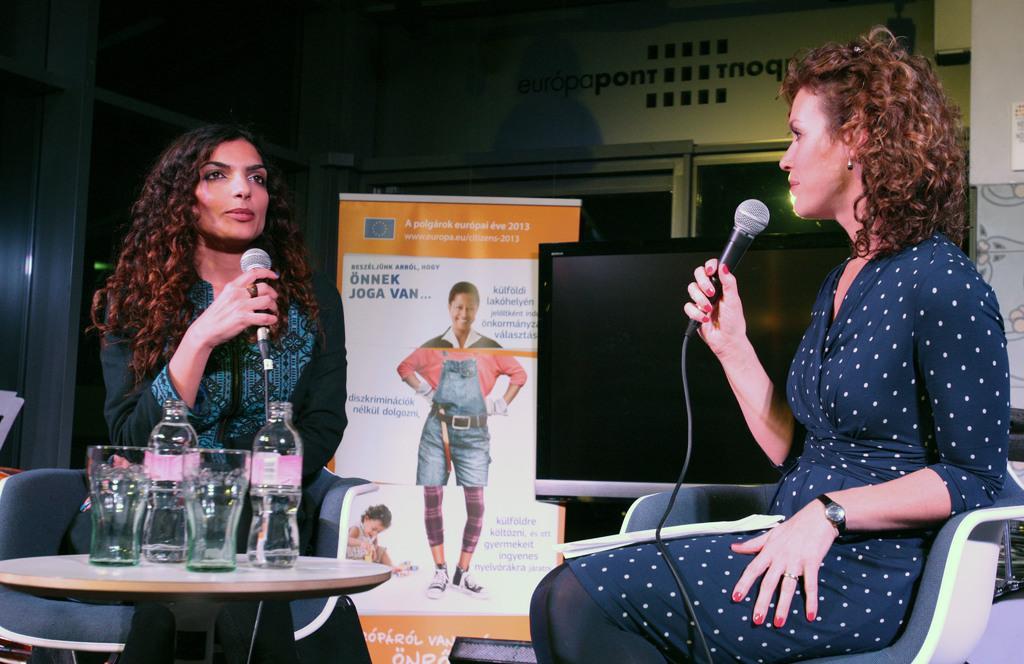In one or two sentences, can you explain what this image depicts? This is a picture taken in a room, there are two women's are sitting on chairs and holding microphones. In front of the women's there is a table on the table there are glasses and bottles. Behind the people is a television, banner and a wall. 